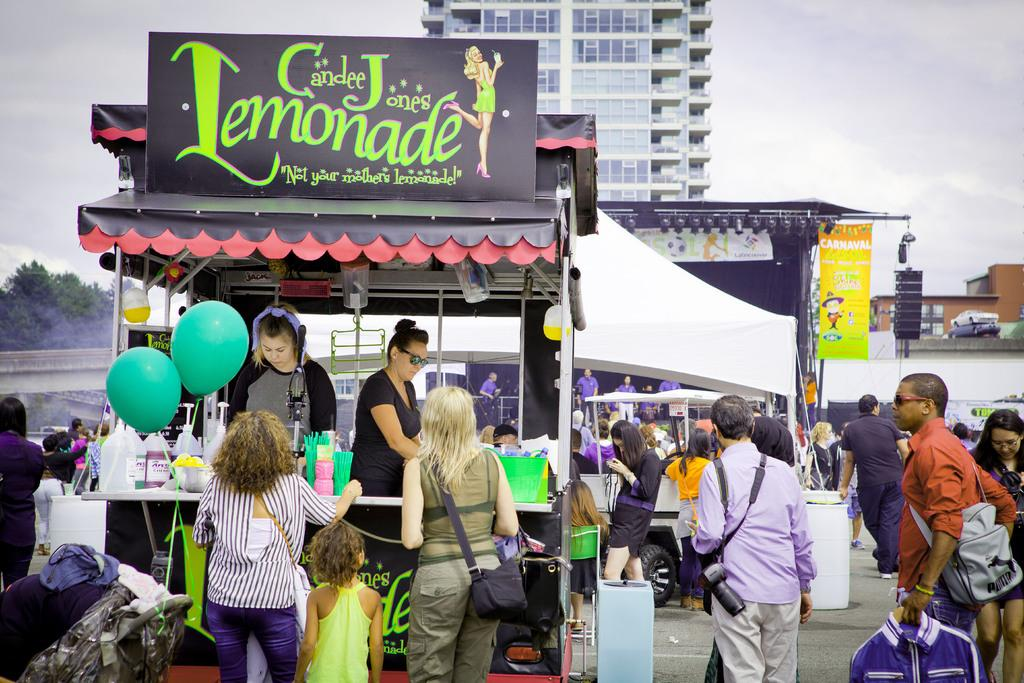What type of surface can be seen in the image? There is ground visible in the image. What structures are present in the image? There are stalls in the image. Can you describe the people in the image? There are people in the image. What type of transportation is visible in the image? There are vehicles in the image. What kind of tent can be seen in the image? There is a white-colored tent in the image. What type of illumination is present in the image? There are lights in the image. What can be seen in the background of the image? There are buildings, trees, and the sky visible in the background of the image. Where is the hole that people are jumping into in the image? There is no hole present in the image. 